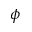Convert formula to latex. <formula><loc_0><loc_0><loc_500><loc_500>\phi</formula> 